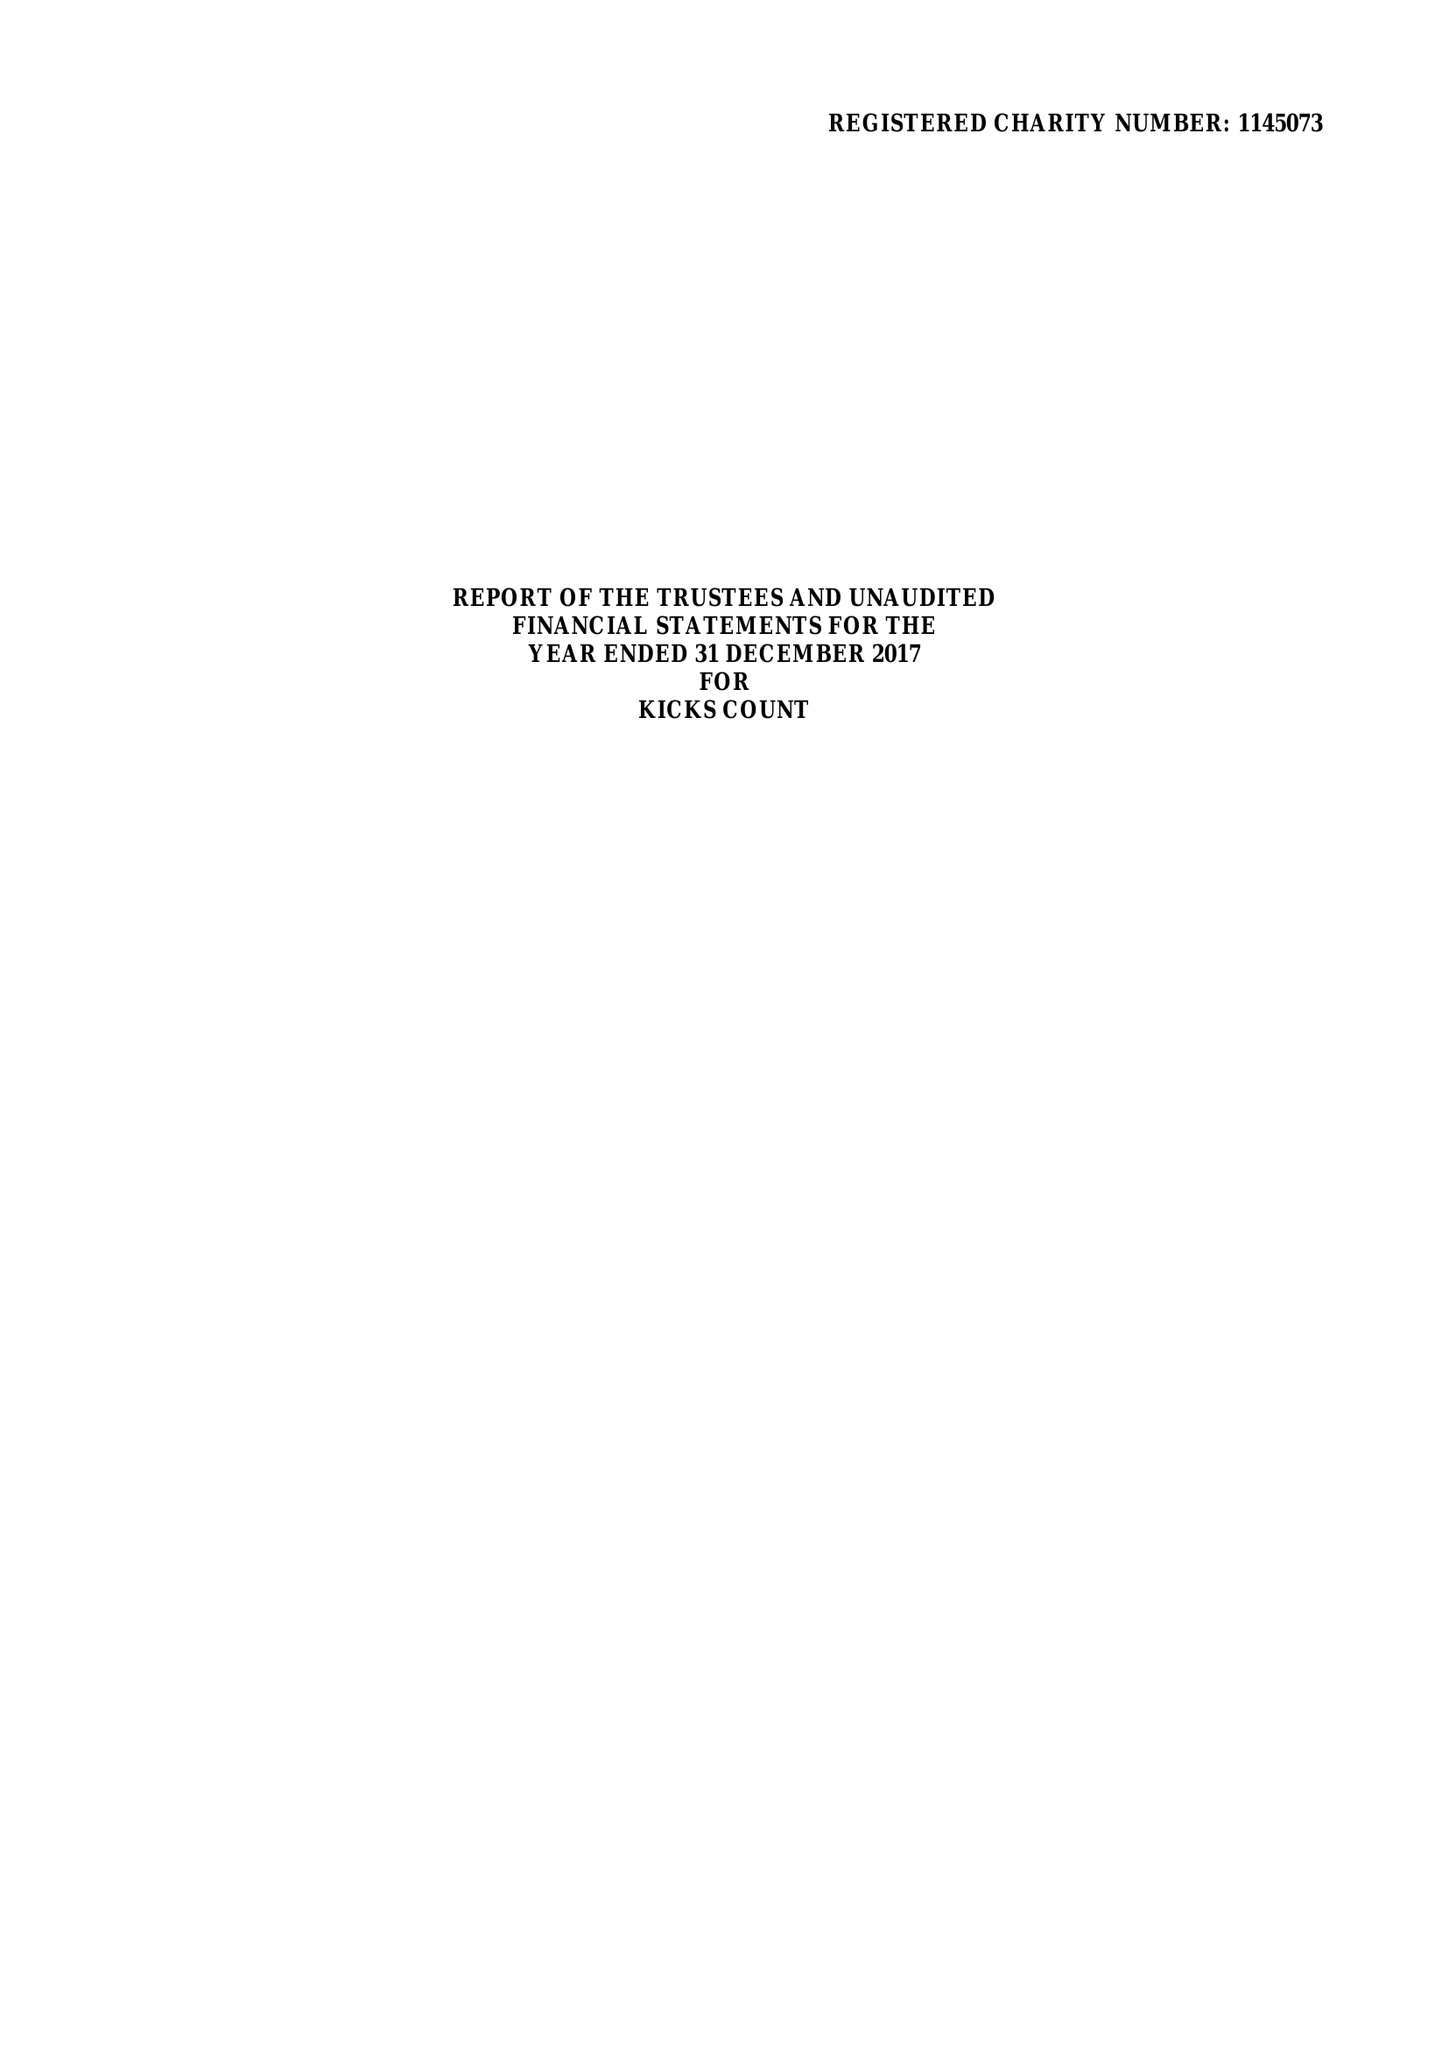What is the value for the income_annually_in_british_pounds?
Answer the question using a single word or phrase. 195749.00 